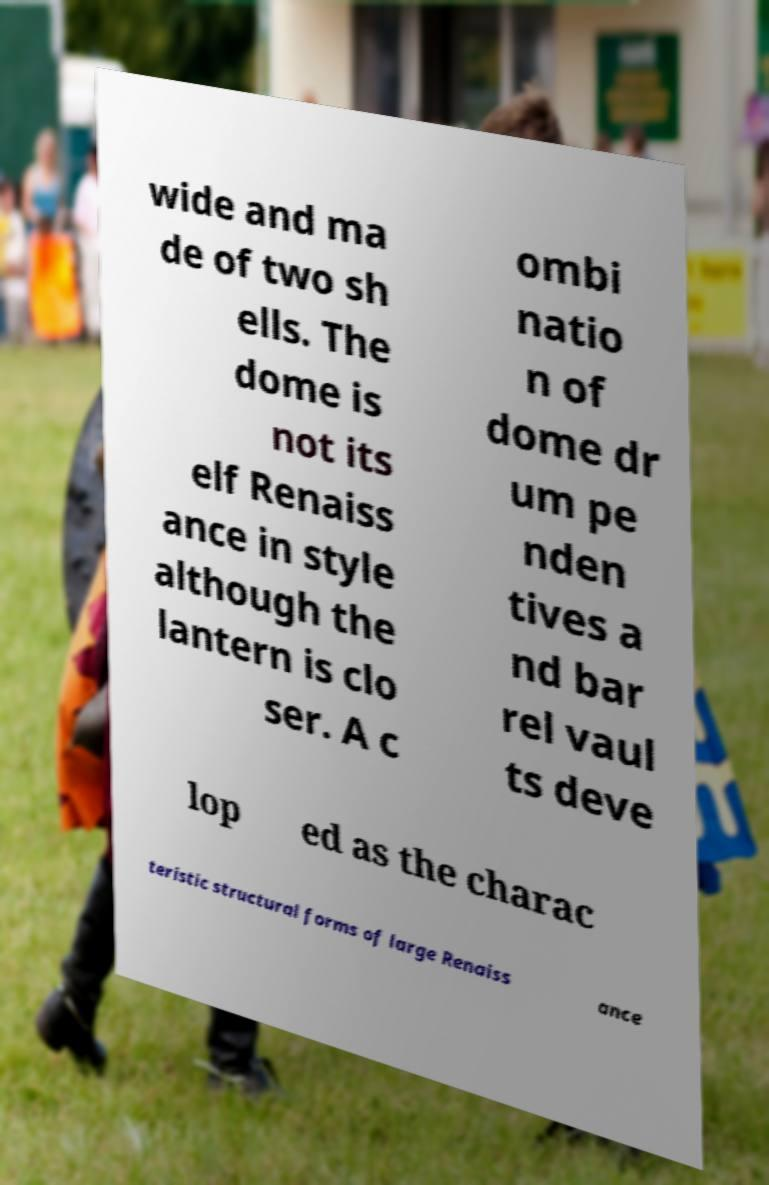Could you assist in decoding the text presented in this image and type it out clearly? wide and ma de of two sh ells. The dome is not its elf Renaiss ance in style although the lantern is clo ser. A c ombi natio n of dome dr um pe nden tives a nd bar rel vaul ts deve lop ed as the charac teristic structural forms of large Renaiss ance 